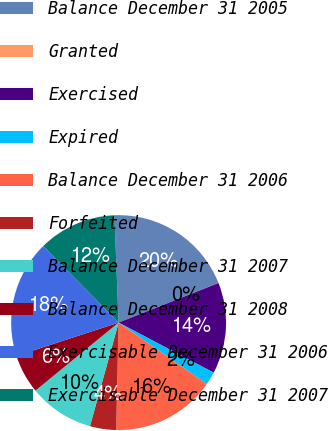Convert chart to OTSL. <chart><loc_0><loc_0><loc_500><loc_500><pie_chart><fcel>Balance December 31 2005<fcel>Granted<fcel>Exercised<fcel>Expired<fcel>Balance December 31 2006<fcel>Forfeited<fcel>Balance December 31 2007<fcel>Balance December 31 2008<fcel>Exercisable December 31 2006<fcel>Exercisable December 31 2007<nl><fcel>19.59%<fcel>0.02%<fcel>13.72%<fcel>1.98%<fcel>15.67%<fcel>3.93%<fcel>9.8%<fcel>5.89%<fcel>17.63%<fcel>11.76%<nl></chart> 